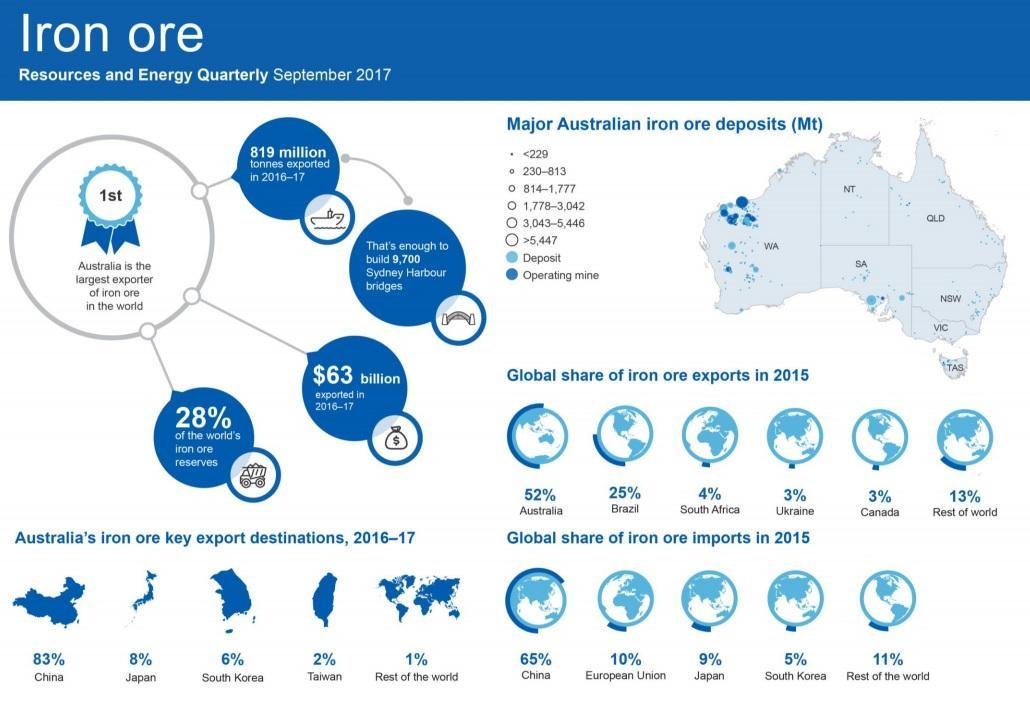How many regions has Australia been divided into based iron ore deposit?
Answer the question with a short phrase. 7 How many key destinations does Australia export iron ore to ? 5 What is the total share of iron exports of Australia, Brazil, South Africa, Ukraine and Canada? 87% Which country has the second lowest share of Iron ore imports in 2015? Japan Which area has the largest representation of operating mines? WA 